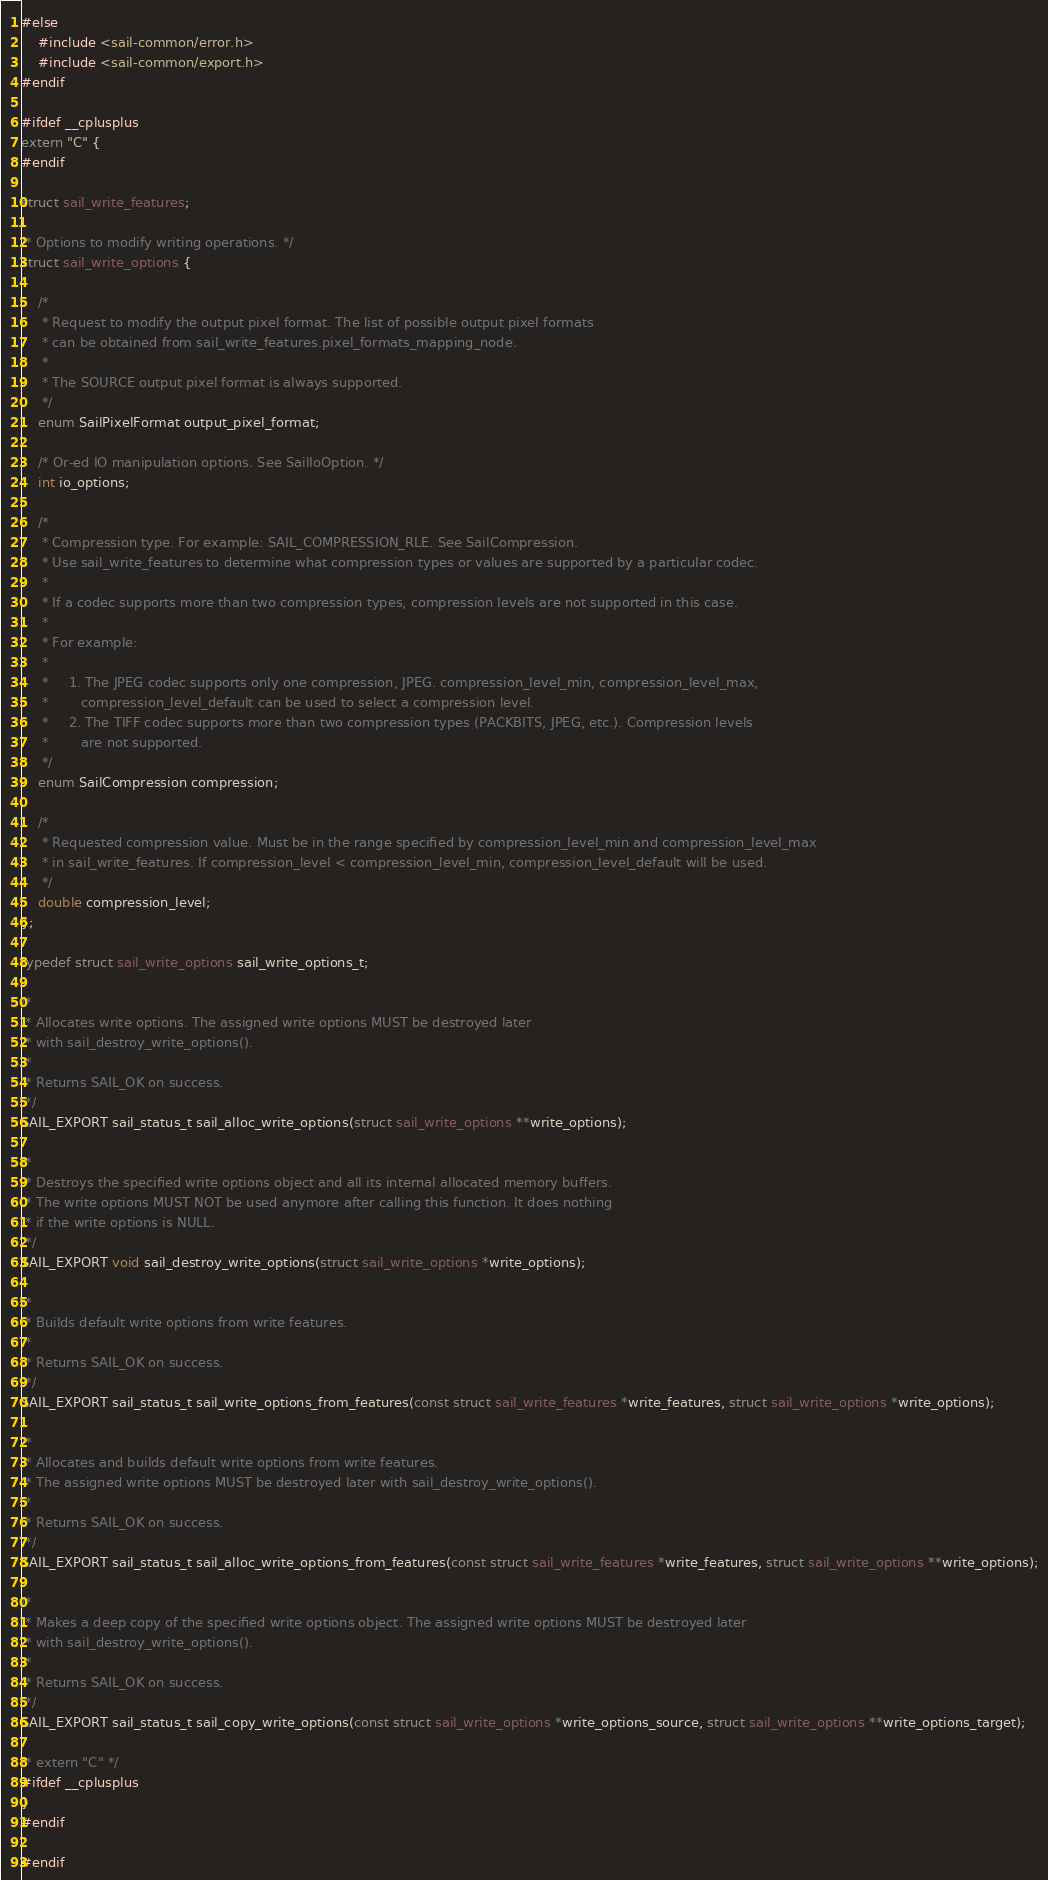<code> <loc_0><loc_0><loc_500><loc_500><_C_>#else
    #include <sail-common/error.h>
    #include <sail-common/export.h>
#endif

#ifdef __cplusplus
extern "C" {
#endif

struct sail_write_features;

/* Options to modify writing operations. */
struct sail_write_options {

    /*
     * Request to modify the output pixel format. The list of possible output pixel formats
     * can be obtained from sail_write_features.pixel_formats_mapping_node.
     *
     * The SOURCE output pixel format is always supported.
     */
    enum SailPixelFormat output_pixel_format;

    /* Or-ed IO manipulation options. See SailIoOption. */
    int io_options;

    /*
     * Compression type. For example: SAIL_COMPRESSION_RLE. See SailCompression.
     * Use sail_write_features to determine what compression types or values are supported by a particular codec.
     *
     * If a codec supports more than two compression types, compression levels are not supported in this case.
     *
     * For example:
     *
     *     1. The JPEG codec supports only one compression, JPEG. compression_level_min, compression_level_max,
     *        compression_level_default can be used to select a compression level.
     *     2. The TIFF codec supports more than two compression types (PACKBITS, JPEG, etc.). Compression levels
     *        are not supported.
     */
    enum SailCompression compression;

    /*
     * Requested compression value. Must be in the range specified by compression_level_min and compression_level_max
     * in sail_write_features. If compression_level < compression_level_min, compression_level_default will be used.
     */
    double compression_level;
};

typedef struct sail_write_options sail_write_options_t;

/*
 * Allocates write options. The assigned write options MUST be destroyed later
 * with sail_destroy_write_options().
 *
 * Returns SAIL_OK on success.
 */
SAIL_EXPORT sail_status_t sail_alloc_write_options(struct sail_write_options **write_options);

/*
 * Destroys the specified write options object and all its internal allocated memory buffers.
 * The write options MUST NOT be used anymore after calling this function. It does nothing
 * if the write options is NULL.
 */
SAIL_EXPORT void sail_destroy_write_options(struct sail_write_options *write_options);

/*
 * Builds default write options from write features.
 *
 * Returns SAIL_OK on success.
 */
SAIL_EXPORT sail_status_t sail_write_options_from_features(const struct sail_write_features *write_features, struct sail_write_options *write_options);

/*
 * Allocates and builds default write options from write features.
 * The assigned write options MUST be destroyed later with sail_destroy_write_options().
 *
 * Returns SAIL_OK on success.
 */
SAIL_EXPORT sail_status_t sail_alloc_write_options_from_features(const struct sail_write_features *write_features, struct sail_write_options **write_options);

/*
 * Makes a deep copy of the specified write options object. The assigned write options MUST be destroyed later
 * with sail_destroy_write_options().
 *
 * Returns SAIL_OK on success.
 */
SAIL_EXPORT sail_status_t sail_copy_write_options(const struct sail_write_options *write_options_source, struct sail_write_options **write_options_target);

/* extern "C" */
#ifdef __cplusplus
}
#endif

#endif
</code> 